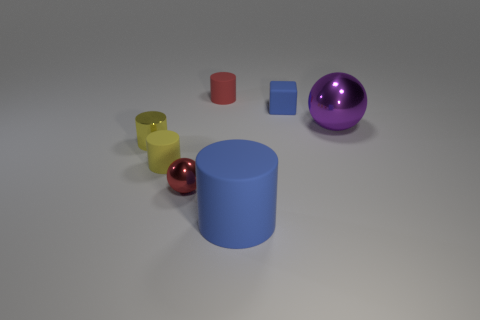Add 1 large red shiny cylinders. How many objects exist? 8 Subtract all cylinders. How many objects are left? 3 Subtract all red spheres. Subtract all cylinders. How many objects are left? 2 Add 4 blocks. How many blocks are left? 5 Add 4 yellow matte cylinders. How many yellow matte cylinders exist? 5 Subtract 1 blue cylinders. How many objects are left? 6 